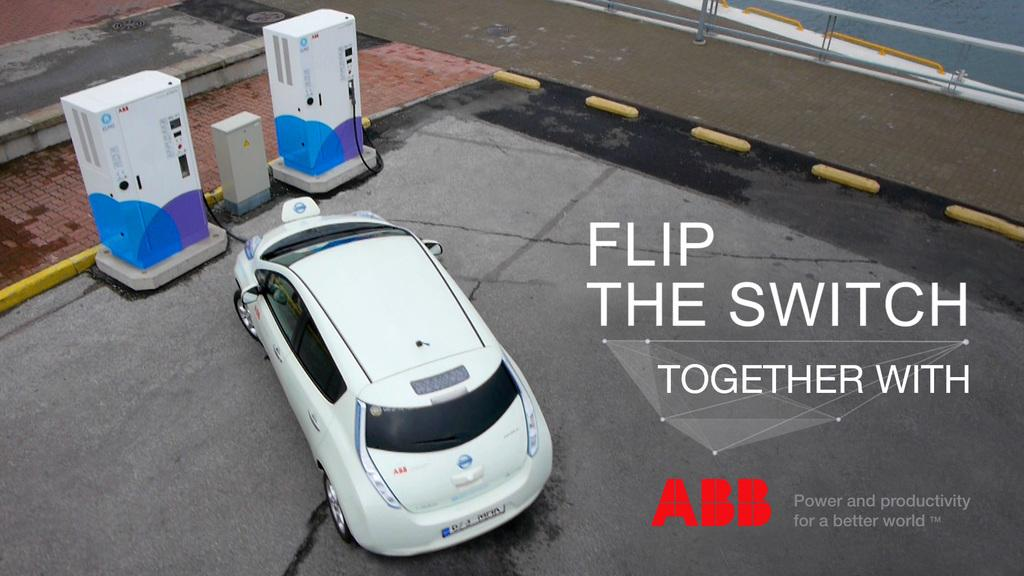What is the main subject of the image? The main subject of the image is a car. What else can be seen in the image besides the car? There are two fuel machines and a wall in the image. Is there any text present in the image? Yes, there is text on the image. Can you tell me how many people are walking in the image? There is no indication of people walking in the image; it primarily features a car, fuel machines, a wall, and text. 